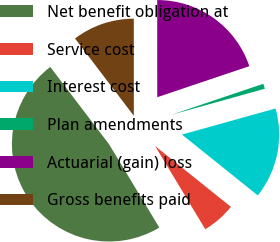<chart> <loc_0><loc_0><loc_500><loc_500><pie_chart><fcel>Net benefit obligation at<fcel>Service cost<fcel>Interest cost<fcel>Plan amendments<fcel>Actuarial (gain) loss<fcel>Gross benefits paid<nl><fcel>48.29%<fcel>5.6%<fcel>15.09%<fcel>0.85%<fcel>19.83%<fcel>10.34%<nl></chart> 